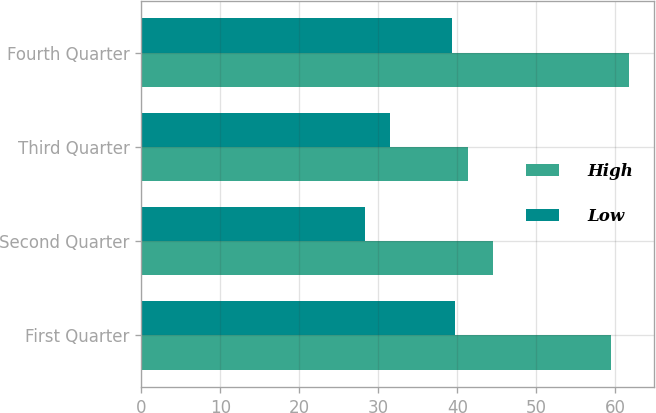Convert chart. <chart><loc_0><loc_0><loc_500><loc_500><stacked_bar_chart><ecel><fcel>First Quarter<fcel>Second Quarter<fcel>Third Quarter<fcel>Fourth Quarter<nl><fcel>High<fcel>59.47<fcel>44.45<fcel>41.32<fcel>61.74<nl><fcel>Low<fcel>39.72<fcel>28.36<fcel>31.51<fcel>39.32<nl></chart> 